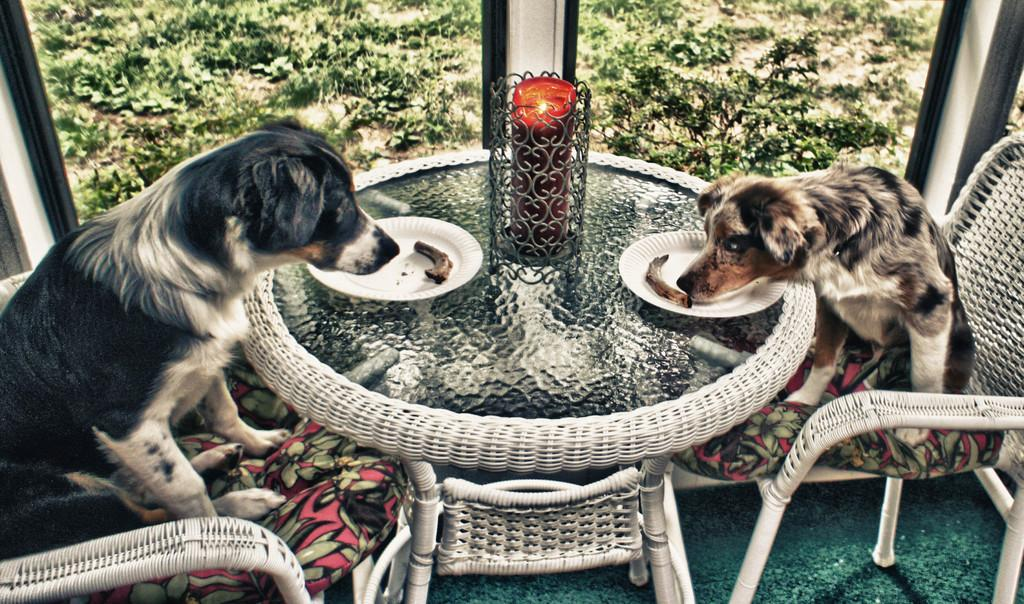What type of vegetation can be seen in the image? There are trees in the image. What type of furniture is visible in the image? There are chairs and a table in the image. What is placed on the table in the image? There are plates and a candle on the table. Are there any animals present in the image? Yes, there are two dogs in the image. What type of record can be seen in the image? There is no record present in the image. What action are the dogs performing in the image? The provided facts do not specify any actions performed by the dogs in the image. 